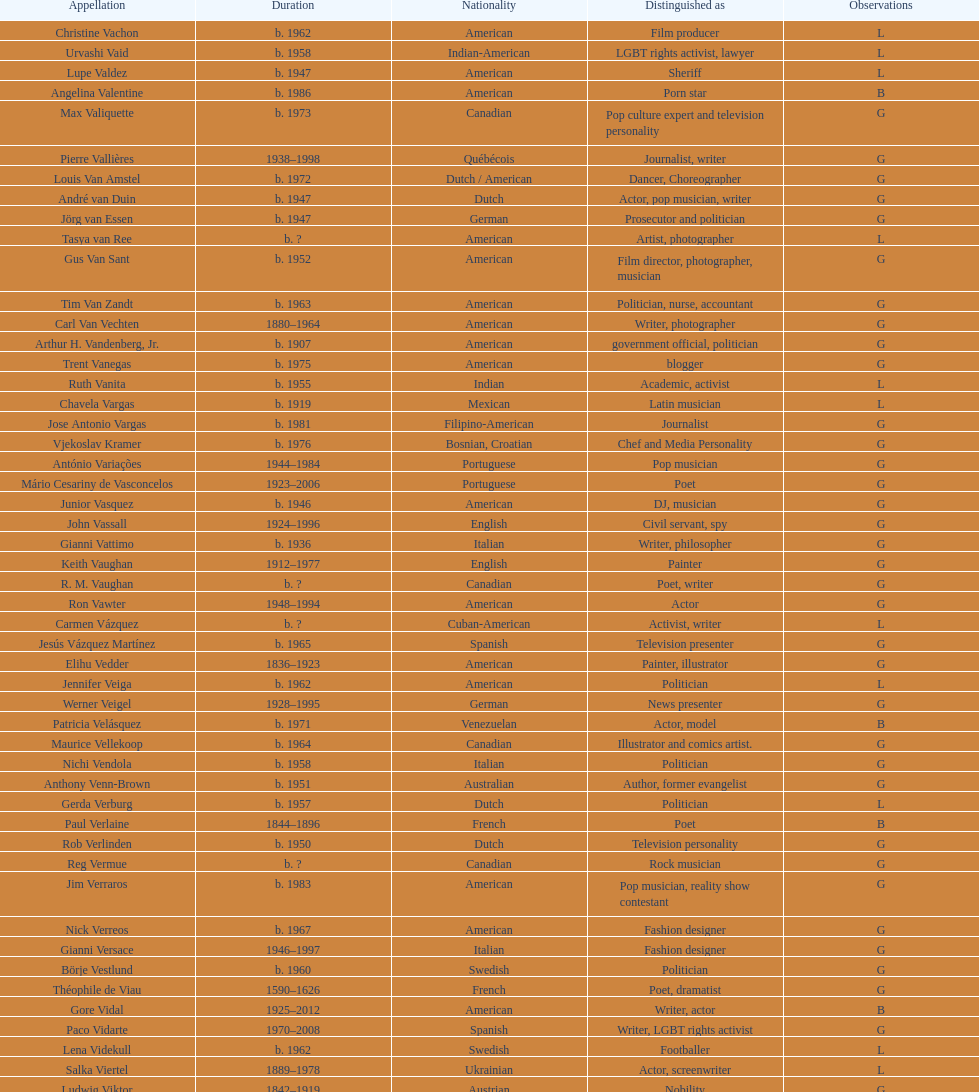Which nationality has the most people associated with it? American. 